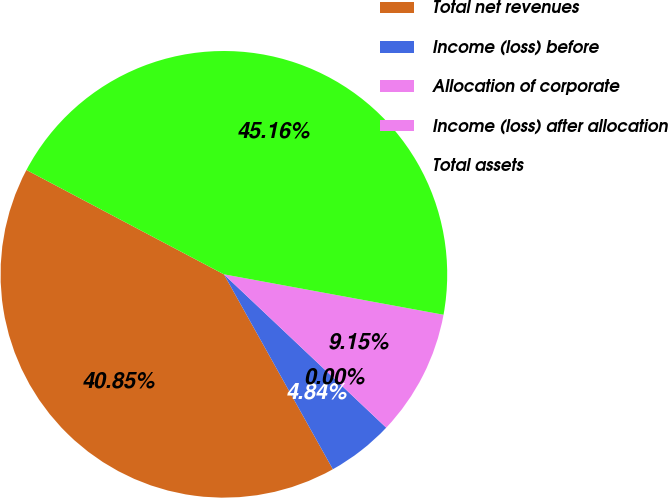<chart> <loc_0><loc_0><loc_500><loc_500><pie_chart><fcel>Total net revenues<fcel>Income (loss) before<fcel>Allocation of corporate<fcel>Income (loss) after allocation<fcel>Total assets<nl><fcel>40.85%<fcel>4.84%<fcel>0.0%<fcel>9.15%<fcel>45.16%<nl></chart> 